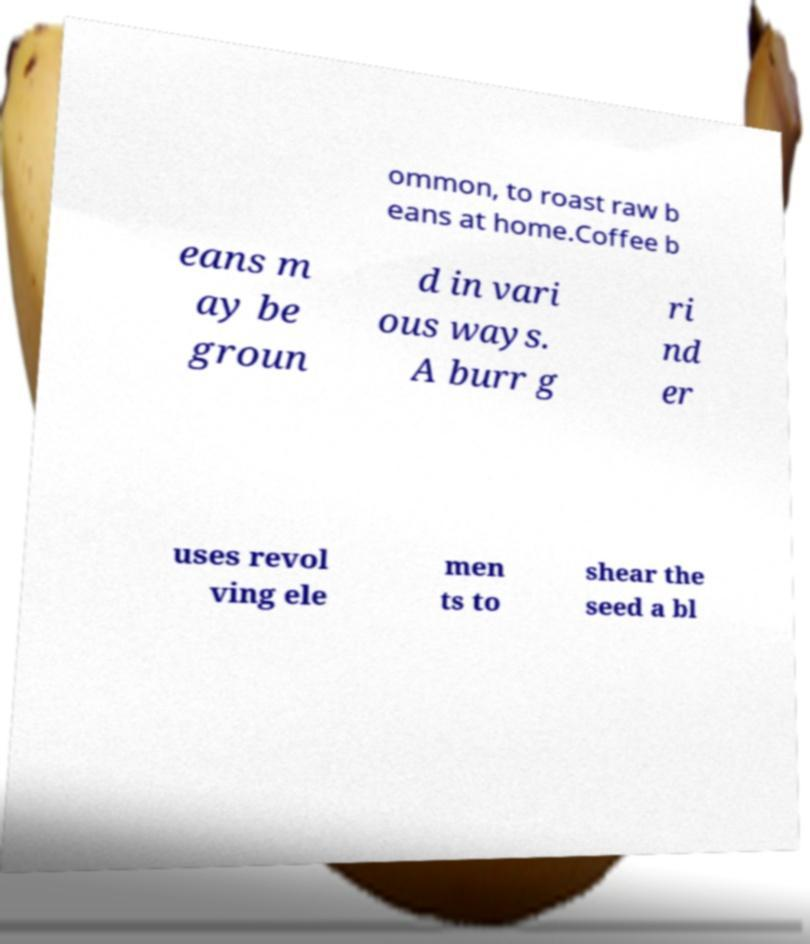Please identify and transcribe the text found in this image. ommon, to roast raw b eans at home.Coffee b eans m ay be groun d in vari ous ways. A burr g ri nd er uses revol ving ele men ts to shear the seed a bl 